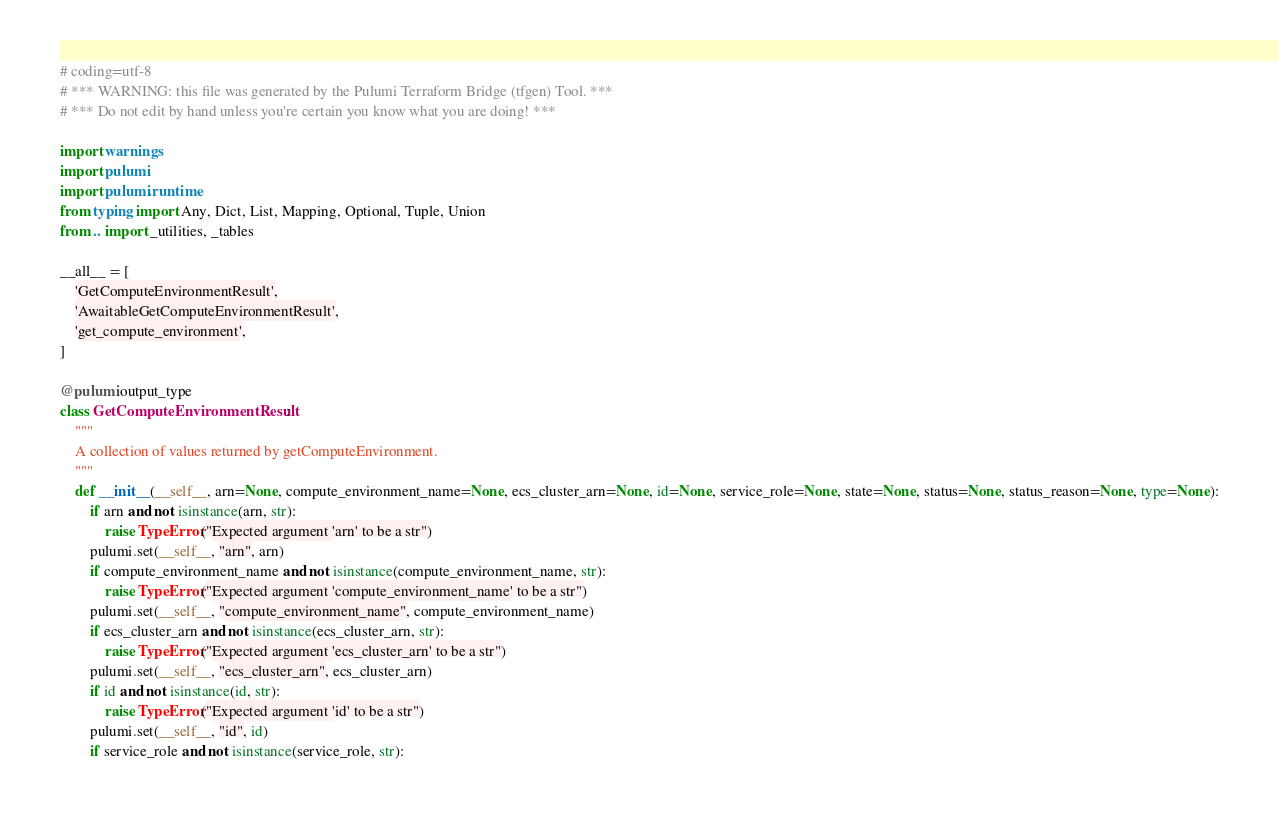<code> <loc_0><loc_0><loc_500><loc_500><_Python_># coding=utf-8
# *** WARNING: this file was generated by the Pulumi Terraform Bridge (tfgen) Tool. ***
# *** Do not edit by hand unless you're certain you know what you are doing! ***

import warnings
import pulumi
import pulumi.runtime
from typing import Any, Dict, List, Mapping, Optional, Tuple, Union
from .. import _utilities, _tables

__all__ = [
    'GetComputeEnvironmentResult',
    'AwaitableGetComputeEnvironmentResult',
    'get_compute_environment',
]

@pulumi.output_type
class GetComputeEnvironmentResult:
    """
    A collection of values returned by getComputeEnvironment.
    """
    def __init__(__self__, arn=None, compute_environment_name=None, ecs_cluster_arn=None, id=None, service_role=None, state=None, status=None, status_reason=None, type=None):
        if arn and not isinstance(arn, str):
            raise TypeError("Expected argument 'arn' to be a str")
        pulumi.set(__self__, "arn", arn)
        if compute_environment_name and not isinstance(compute_environment_name, str):
            raise TypeError("Expected argument 'compute_environment_name' to be a str")
        pulumi.set(__self__, "compute_environment_name", compute_environment_name)
        if ecs_cluster_arn and not isinstance(ecs_cluster_arn, str):
            raise TypeError("Expected argument 'ecs_cluster_arn' to be a str")
        pulumi.set(__self__, "ecs_cluster_arn", ecs_cluster_arn)
        if id and not isinstance(id, str):
            raise TypeError("Expected argument 'id' to be a str")
        pulumi.set(__self__, "id", id)
        if service_role and not isinstance(service_role, str):</code> 